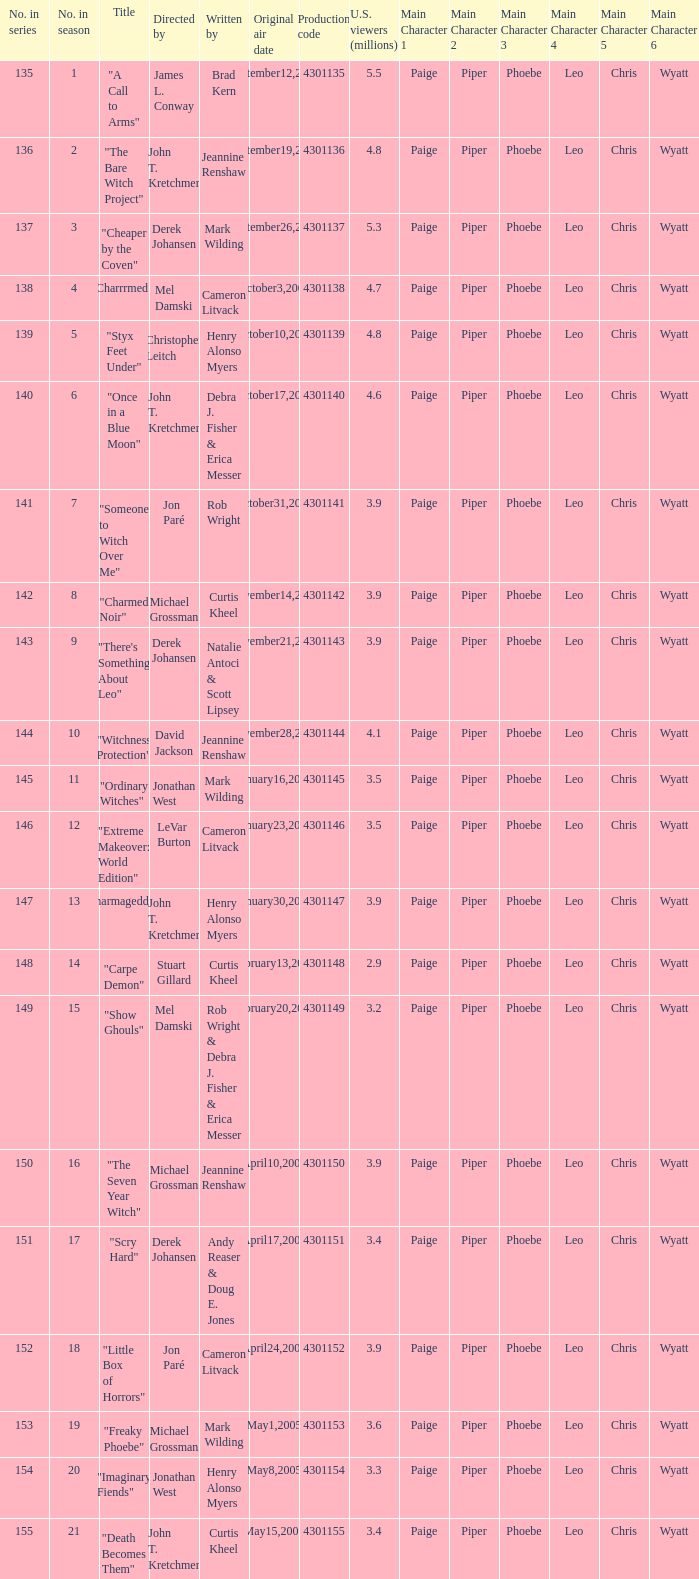What is the no in series when rob wright & debra j. fisher & erica messer were the writers? 149.0. 